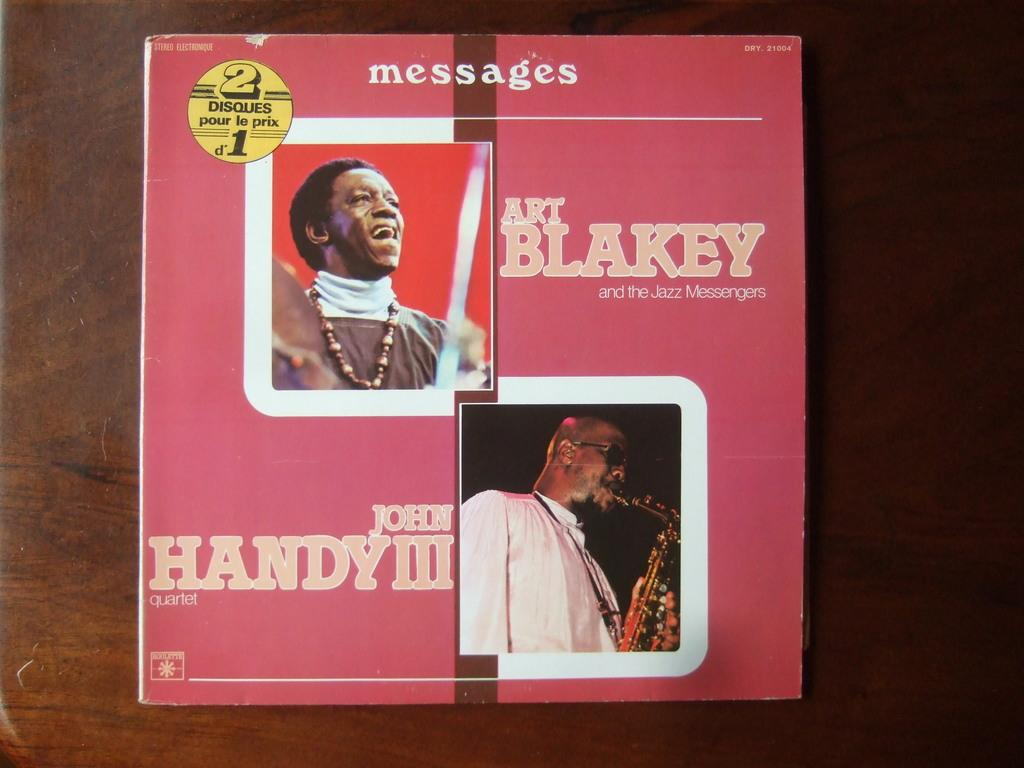<image>
Describe the image concisely. A copy of the book Messages featuring Art Blakey and John handy III. 